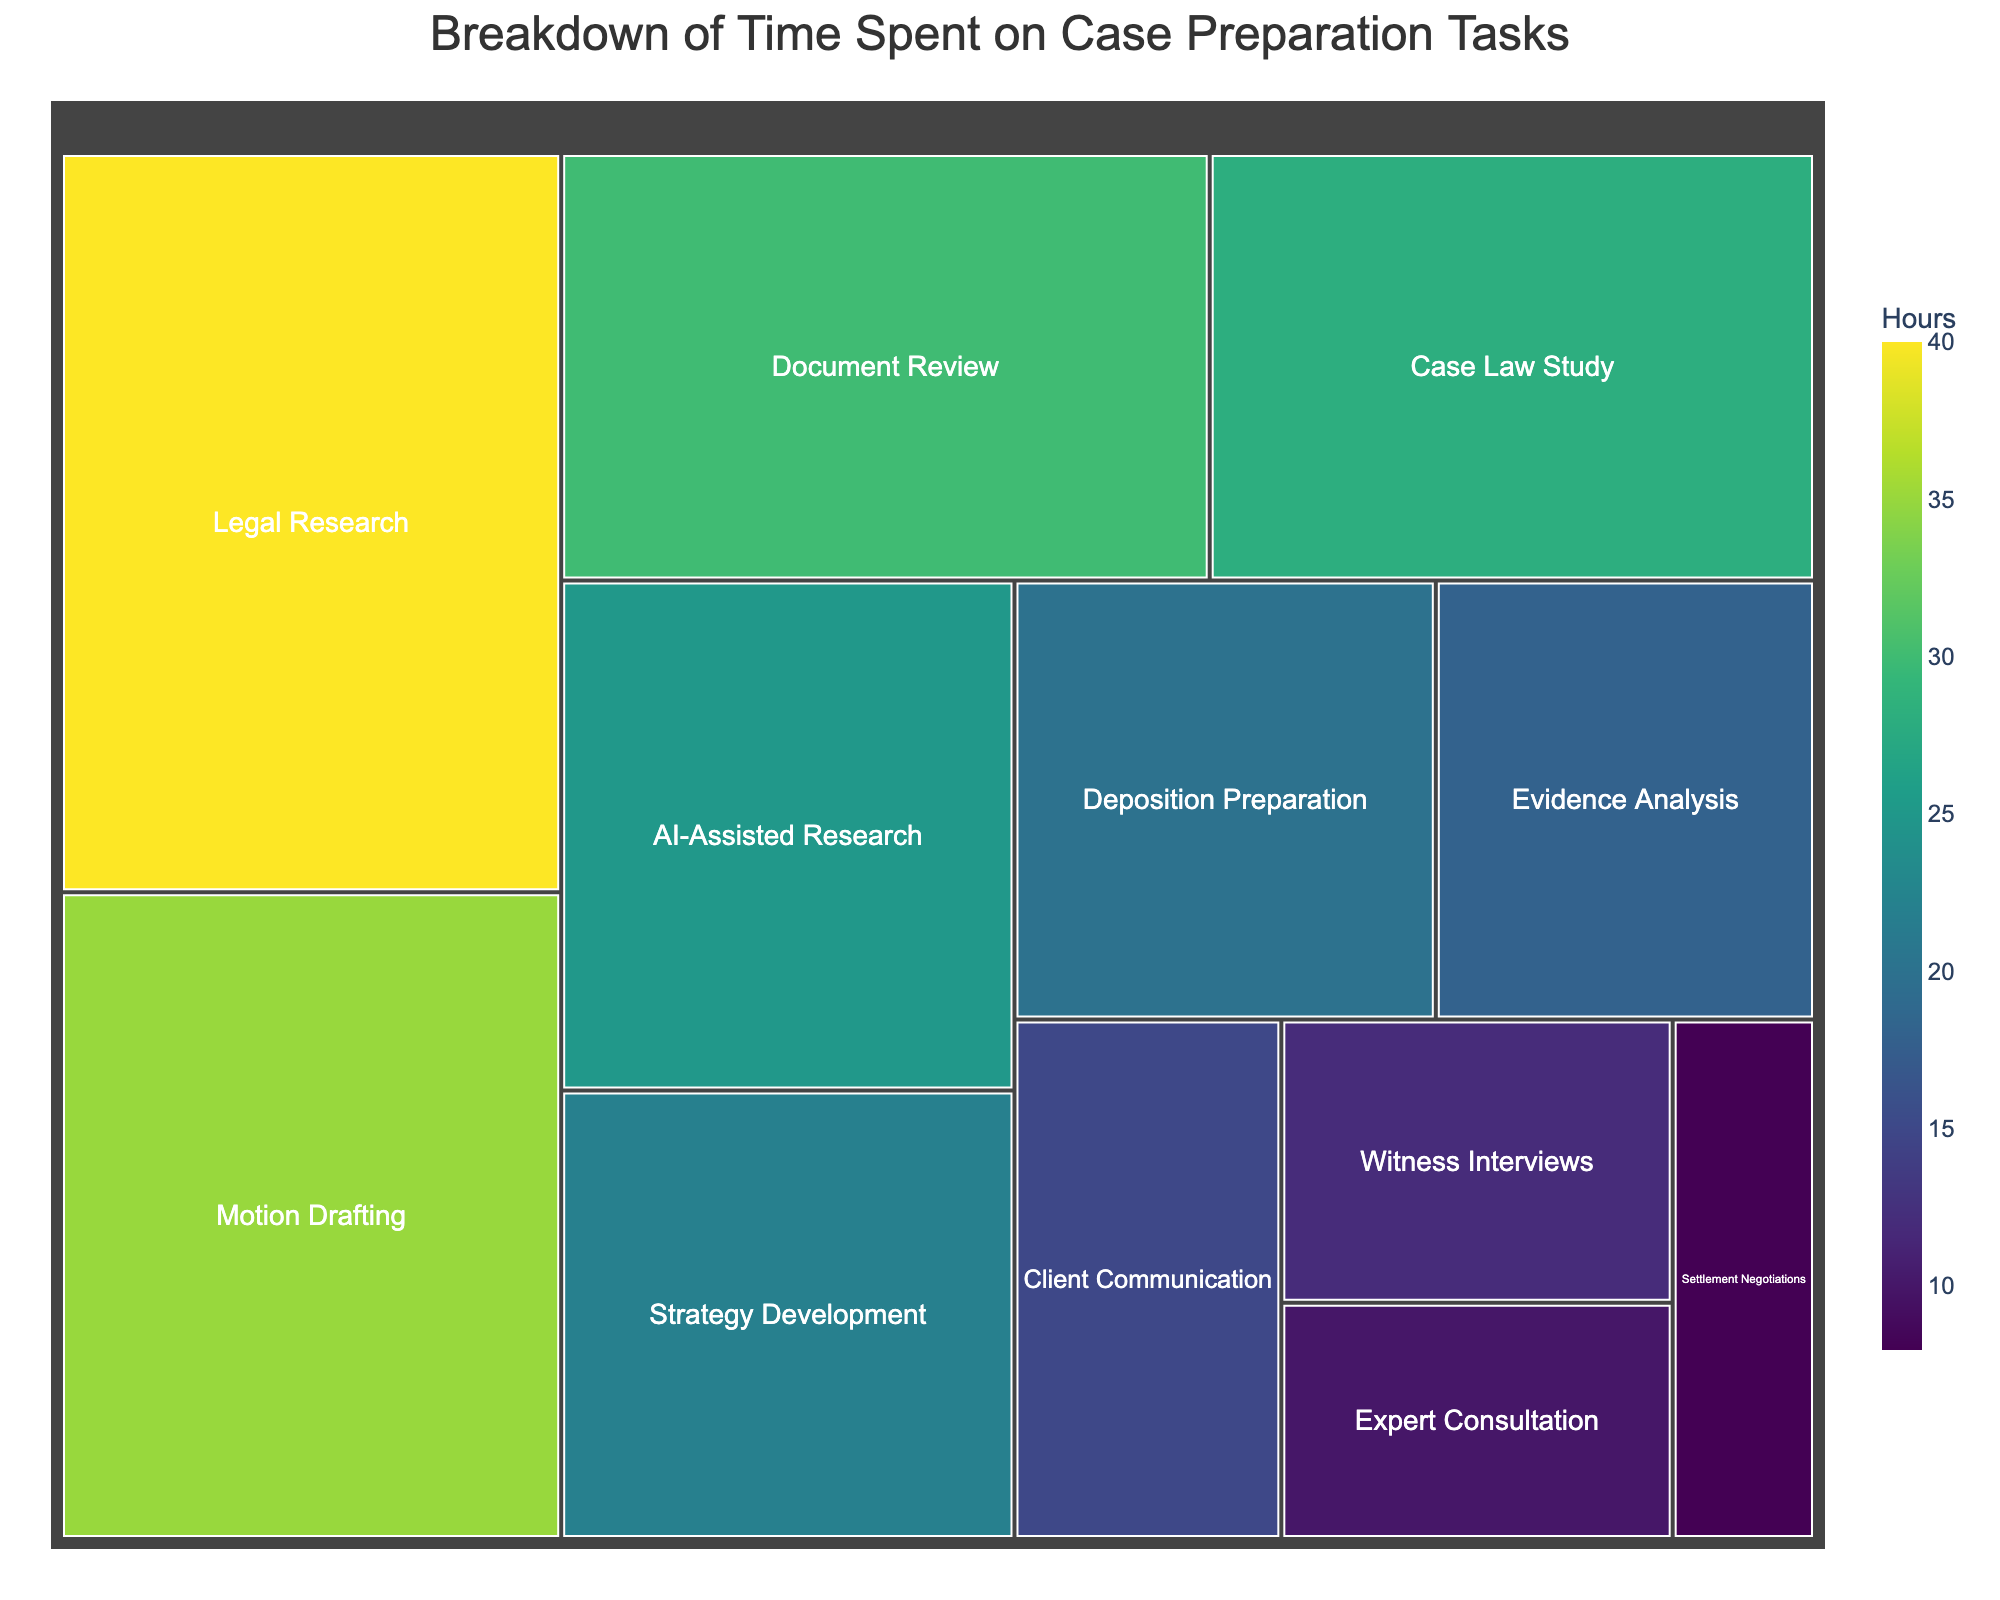What task consumes the most time according to the treemap? Look for the task with the largest area; in this case, identify the block with the largest size within the treemap and verify from the data.
Answer: Legal Research Which task has the least amount of time spent on it? Identify the smallest block in the treemap and confirm with the data.
Answer: Settlement Negotiations How much more time is spent on Motion Drafting compared to AI-Assisted Research? Find the blocks for both tasks and note their time values. Subtract the time spent on AI-Assisted Research from Motion Drafting.
Answer: 10 hours What percentage of the total time is dedicated to AI-Assisted Research? Sum the total hours from all tasks and calculate the percentage of the total time attributed to AI-Assisted Research.
Answer: 11.42% Are there more hours spent on Strategy Development or Evidence Analysis? Compare the two sizes of the blocks for Strategy Development and Evidence Analysis and verify from the data.
Answer: Strategy Development How many tasks have more hours dedicated to them than Document Review? Identify the value for Document Review and compare it with other tasks, count the ones that have larger values in the treemap.
Answer: 4 tasks What is the combined time spent on Witness Interviews and Expert Consultation? Sum the values for Witness Interviews and Expert Consultation by locating their respective blocks.
Answer: 22 hours Is more time spent on Depositions Preparation or Client Communication? Compare the two blocks for Depositions Preparation and Client Communication.
Answer: Depositions Preparation What is the average time spent on all tasks? Add up all the time values from each task and divide by the number of tasks listed in the treemap.
Answer: 22.42 hours What is the title of the treemap? Look at the top of the treemap to find the designated title.
Answer: Breakdown of Time Spent on Case Preparation Tasks 